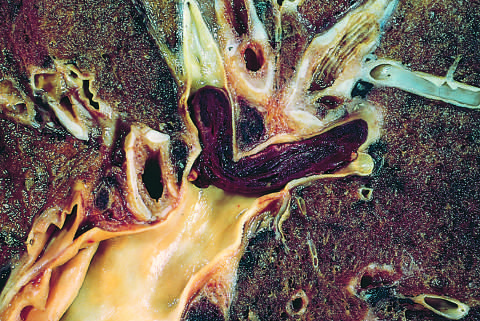s edema lodged in a pulmonary artery branch?
Answer the question using a single word or phrase. No 